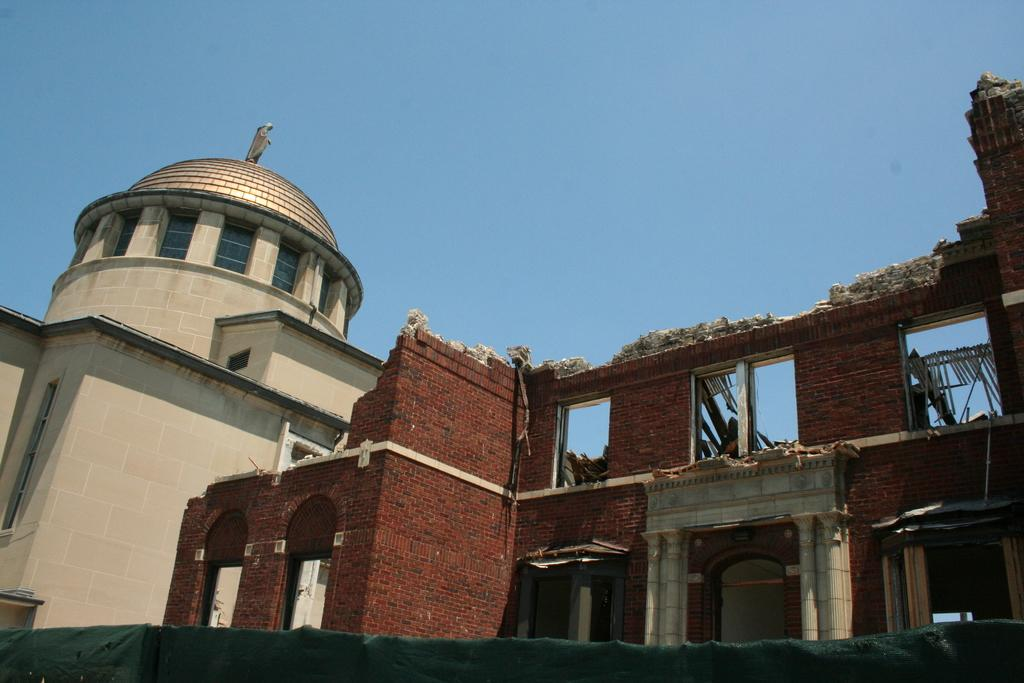What is the condition of the building in the image? The building in the image is broken. What structure is located on the left side of the image? There is a house on the left side of the image. What is visible at the top of the image? The sky is visible at the top of the image. Can you tell me how many pins are holding up the broken building in the image? There are no pins present in the image; the building's condition is described as broken, but no specific cause is mentioned. Is the broken building located near the coast in the image? There is no information about the location of the building or the presence of a coast in the image. 